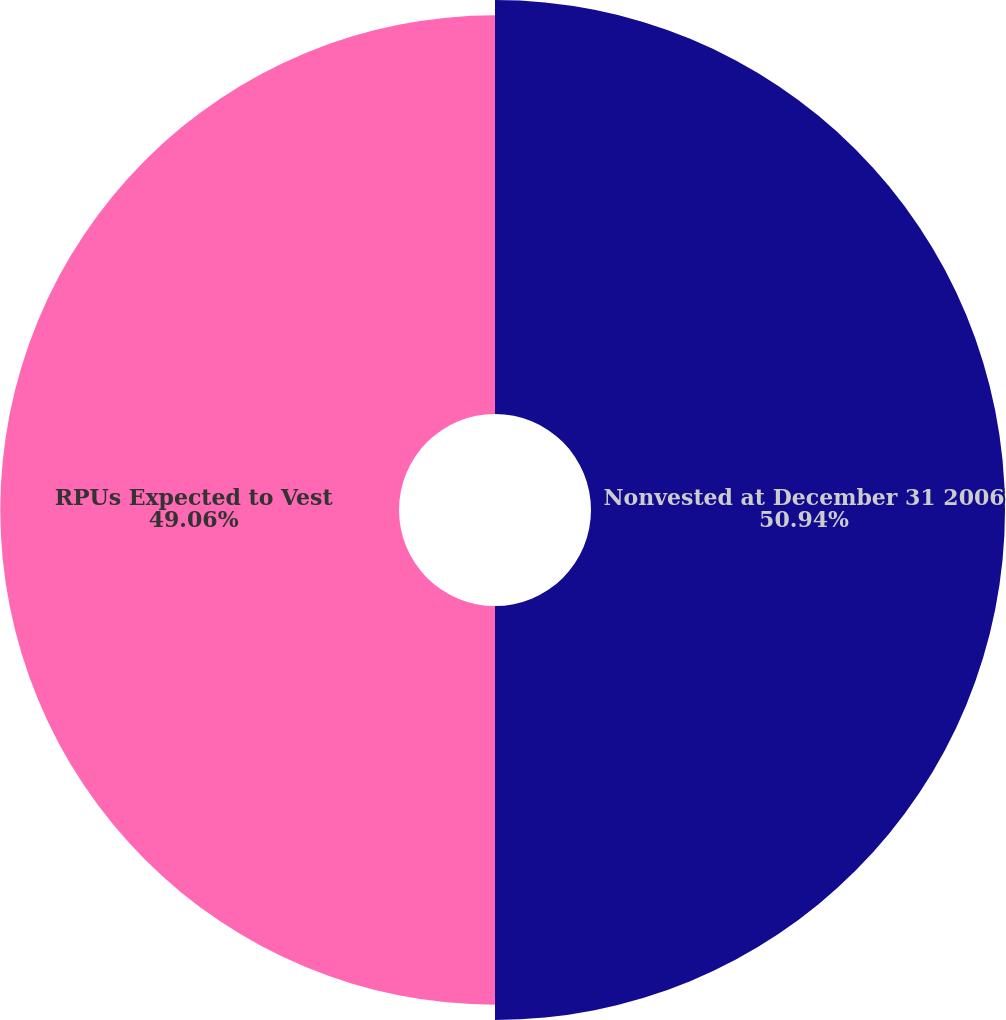Convert chart. <chart><loc_0><loc_0><loc_500><loc_500><pie_chart><fcel>Nonvested at December 31 2006<fcel>RPUs Expected to Vest<nl><fcel>50.94%<fcel>49.06%<nl></chart> 